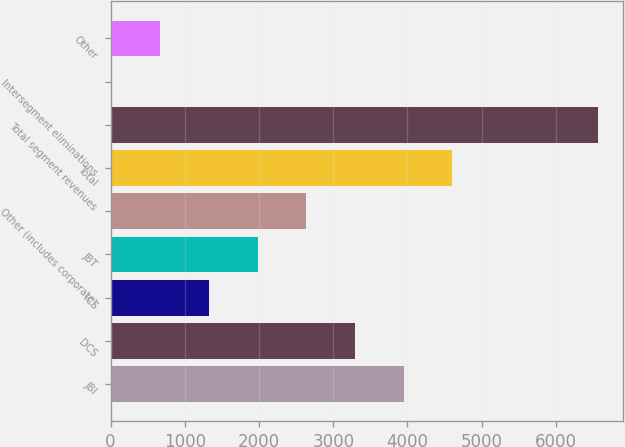Convert chart. <chart><loc_0><loc_0><loc_500><loc_500><bar_chart><fcel>JBI<fcel>DCS<fcel>ICS<fcel>JBT<fcel>Other (includes corporate)<fcel>Total<fcel>Total segment revenues<fcel>Intersegment eliminations<fcel>Other<nl><fcel>3947<fcel>3291.5<fcel>1325<fcel>1980.5<fcel>2636<fcel>4602.5<fcel>6569<fcel>14<fcel>669.5<nl></chart> 